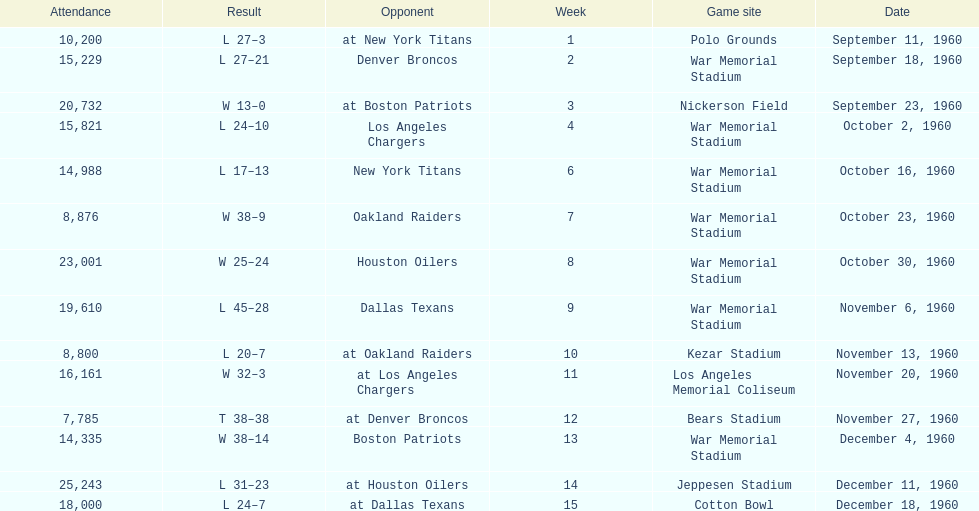How many instances was war memorial stadium the venue for games? 6. 